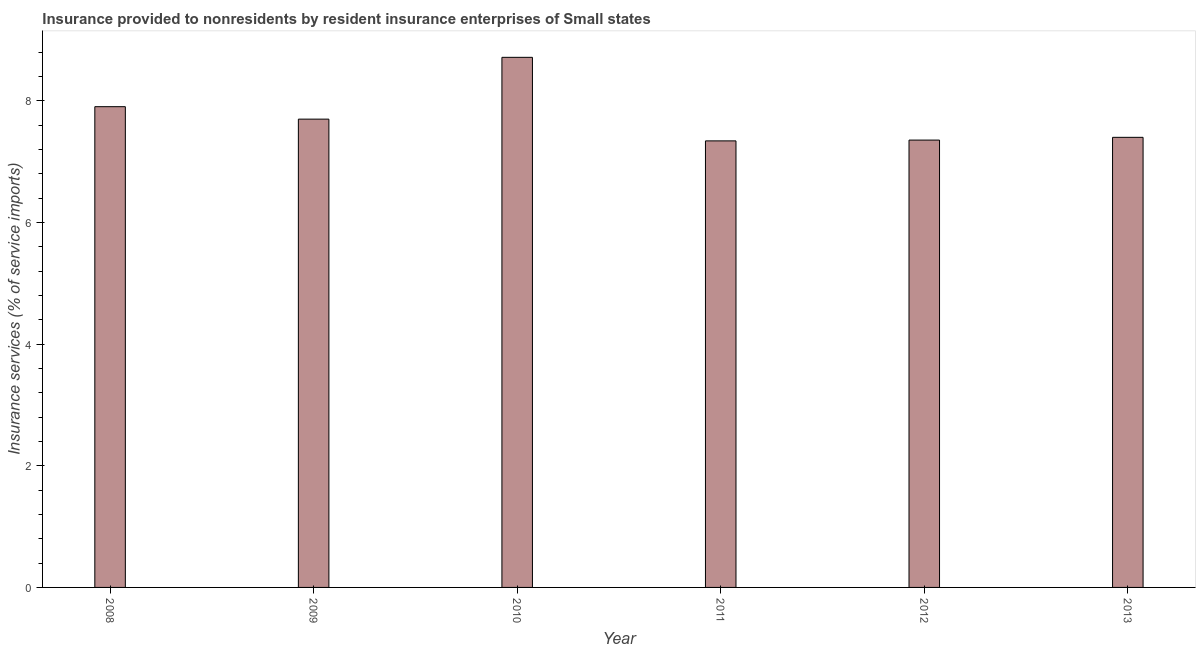Does the graph contain grids?
Make the answer very short. No. What is the title of the graph?
Your answer should be very brief. Insurance provided to nonresidents by resident insurance enterprises of Small states. What is the label or title of the Y-axis?
Provide a succinct answer. Insurance services (% of service imports). What is the insurance and financial services in 2011?
Provide a short and direct response. 7.34. Across all years, what is the maximum insurance and financial services?
Give a very brief answer. 8.72. Across all years, what is the minimum insurance and financial services?
Your response must be concise. 7.34. What is the sum of the insurance and financial services?
Make the answer very short. 46.42. What is the difference between the insurance and financial services in 2008 and 2009?
Your response must be concise. 0.2. What is the average insurance and financial services per year?
Give a very brief answer. 7.74. What is the median insurance and financial services?
Your answer should be compact. 7.55. In how many years, is the insurance and financial services greater than 5.2 %?
Give a very brief answer. 6. Do a majority of the years between 2010 and 2013 (inclusive) have insurance and financial services greater than 2.8 %?
Your answer should be compact. Yes. What is the ratio of the insurance and financial services in 2008 to that in 2012?
Ensure brevity in your answer.  1.07. Is the insurance and financial services in 2008 less than that in 2012?
Offer a very short reply. No. What is the difference between the highest and the second highest insurance and financial services?
Your response must be concise. 0.81. What is the difference between the highest and the lowest insurance and financial services?
Your answer should be very brief. 1.37. Are all the bars in the graph horizontal?
Provide a succinct answer. No. Are the values on the major ticks of Y-axis written in scientific E-notation?
Your response must be concise. No. What is the Insurance services (% of service imports) in 2008?
Keep it short and to the point. 7.91. What is the Insurance services (% of service imports) in 2009?
Give a very brief answer. 7.7. What is the Insurance services (% of service imports) of 2010?
Your answer should be compact. 8.72. What is the Insurance services (% of service imports) of 2011?
Provide a short and direct response. 7.34. What is the Insurance services (% of service imports) in 2012?
Offer a terse response. 7.36. What is the Insurance services (% of service imports) of 2013?
Give a very brief answer. 7.4. What is the difference between the Insurance services (% of service imports) in 2008 and 2009?
Your answer should be compact. 0.2. What is the difference between the Insurance services (% of service imports) in 2008 and 2010?
Your answer should be very brief. -0.81. What is the difference between the Insurance services (% of service imports) in 2008 and 2011?
Ensure brevity in your answer.  0.56. What is the difference between the Insurance services (% of service imports) in 2008 and 2012?
Give a very brief answer. 0.55. What is the difference between the Insurance services (% of service imports) in 2008 and 2013?
Offer a very short reply. 0.5. What is the difference between the Insurance services (% of service imports) in 2009 and 2010?
Your answer should be compact. -1.02. What is the difference between the Insurance services (% of service imports) in 2009 and 2011?
Your answer should be very brief. 0.36. What is the difference between the Insurance services (% of service imports) in 2009 and 2012?
Offer a very short reply. 0.34. What is the difference between the Insurance services (% of service imports) in 2009 and 2013?
Give a very brief answer. 0.3. What is the difference between the Insurance services (% of service imports) in 2010 and 2011?
Ensure brevity in your answer.  1.37. What is the difference between the Insurance services (% of service imports) in 2010 and 2012?
Your response must be concise. 1.36. What is the difference between the Insurance services (% of service imports) in 2010 and 2013?
Offer a very short reply. 1.32. What is the difference between the Insurance services (% of service imports) in 2011 and 2012?
Ensure brevity in your answer.  -0.01. What is the difference between the Insurance services (% of service imports) in 2011 and 2013?
Provide a succinct answer. -0.06. What is the difference between the Insurance services (% of service imports) in 2012 and 2013?
Your response must be concise. -0.05. What is the ratio of the Insurance services (% of service imports) in 2008 to that in 2010?
Give a very brief answer. 0.91. What is the ratio of the Insurance services (% of service imports) in 2008 to that in 2011?
Your answer should be very brief. 1.08. What is the ratio of the Insurance services (% of service imports) in 2008 to that in 2012?
Give a very brief answer. 1.07. What is the ratio of the Insurance services (% of service imports) in 2008 to that in 2013?
Keep it short and to the point. 1.07. What is the ratio of the Insurance services (% of service imports) in 2009 to that in 2010?
Your answer should be compact. 0.88. What is the ratio of the Insurance services (% of service imports) in 2009 to that in 2011?
Ensure brevity in your answer.  1.05. What is the ratio of the Insurance services (% of service imports) in 2009 to that in 2012?
Give a very brief answer. 1.05. What is the ratio of the Insurance services (% of service imports) in 2009 to that in 2013?
Your answer should be compact. 1.04. What is the ratio of the Insurance services (% of service imports) in 2010 to that in 2011?
Make the answer very short. 1.19. What is the ratio of the Insurance services (% of service imports) in 2010 to that in 2012?
Provide a succinct answer. 1.19. What is the ratio of the Insurance services (% of service imports) in 2010 to that in 2013?
Your answer should be compact. 1.18. What is the ratio of the Insurance services (% of service imports) in 2012 to that in 2013?
Your answer should be very brief. 0.99. 